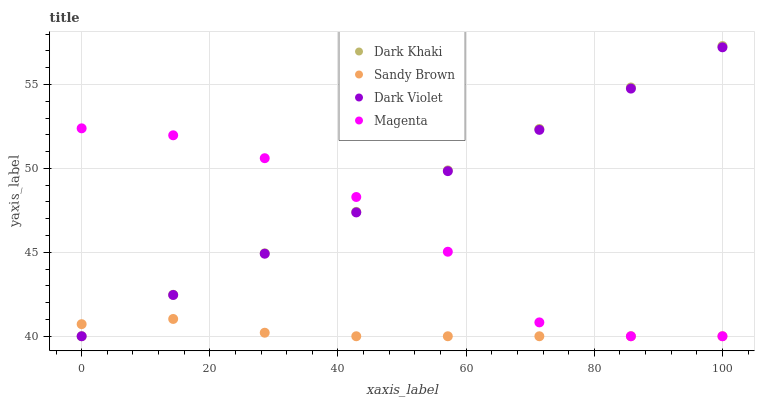Does Sandy Brown have the minimum area under the curve?
Answer yes or no. Yes. Does Dark Khaki have the maximum area under the curve?
Answer yes or no. Yes. Does Magenta have the minimum area under the curve?
Answer yes or no. No. Does Magenta have the maximum area under the curve?
Answer yes or no. No. Is Dark Khaki the smoothest?
Answer yes or no. Yes. Is Magenta the roughest?
Answer yes or no. Yes. Is Sandy Brown the smoothest?
Answer yes or no. No. Is Sandy Brown the roughest?
Answer yes or no. No. Does Dark Khaki have the lowest value?
Answer yes or no. Yes. Does Dark Khaki have the highest value?
Answer yes or no. Yes. Does Magenta have the highest value?
Answer yes or no. No. Does Dark Violet intersect Dark Khaki?
Answer yes or no. Yes. Is Dark Violet less than Dark Khaki?
Answer yes or no. No. Is Dark Violet greater than Dark Khaki?
Answer yes or no. No. 